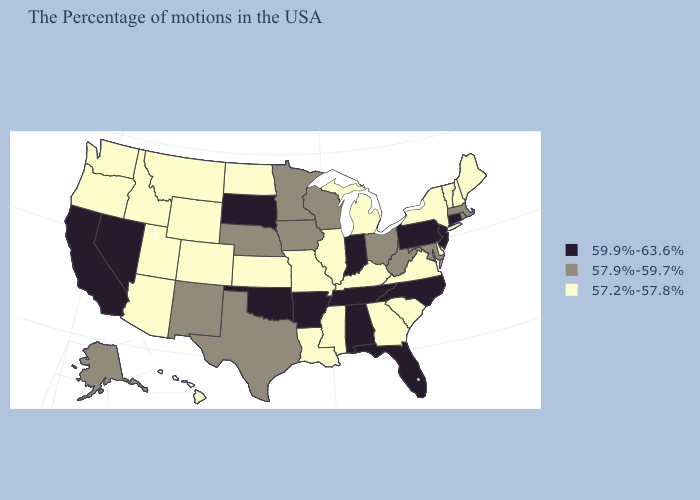Does North Dakota have the lowest value in the MidWest?
Write a very short answer. Yes. What is the lowest value in states that border Rhode Island?
Quick response, please. 57.9%-59.7%. Name the states that have a value in the range 57.9%-59.7%?
Short answer required. Massachusetts, Rhode Island, Maryland, West Virginia, Ohio, Wisconsin, Minnesota, Iowa, Nebraska, Texas, New Mexico, Alaska. What is the value of Texas?
Keep it brief. 57.9%-59.7%. What is the value of Maryland?
Concise answer only. 57.9%-59.7%. What is the lowest value in states that border New Jersey?
Quick response, please. 57.2%-57.8%. Which states have the lowest value in the USA?
Answer briefly. Maine, New Hampshire, Vermont, New York, Delaware, Virginia, South Carolina, Georgia, Michigan, Kentucky, Illinois, Mississippi, Louisiana, Missouri, Kansas, North Dakota, Wyoming, Colorado, Utah, Montana, Arizona, Idaho, Washington, Oregon, Hawaii. Does Alaska have a lower value than Connecticut?
Keep it brief. Yes. Name the states that have a value in the range 57.9%-59.7%?
Write a very short answer. Massachusetts, Rhode Island, Maryland, West Virginia, Ohio, Wisconsin, Minnesota, Iowa, Nebraska, Texas, New Mexico, Alaska. What is the value of Minnesota?
Short answer required. 57.9%-59.7%. Among the states that border California , does Arizona have the lowest value?
Concise answer only. Yes. Which states hav the highest value in the West?
Write a very short answer. Nevada, California. Among the states that border North Dakota , which have the highest value?
Keep it brief. South Dakota. What is the lowest value in states that border South Dakota?
Quick response, please. 57.2%-57.8%. 